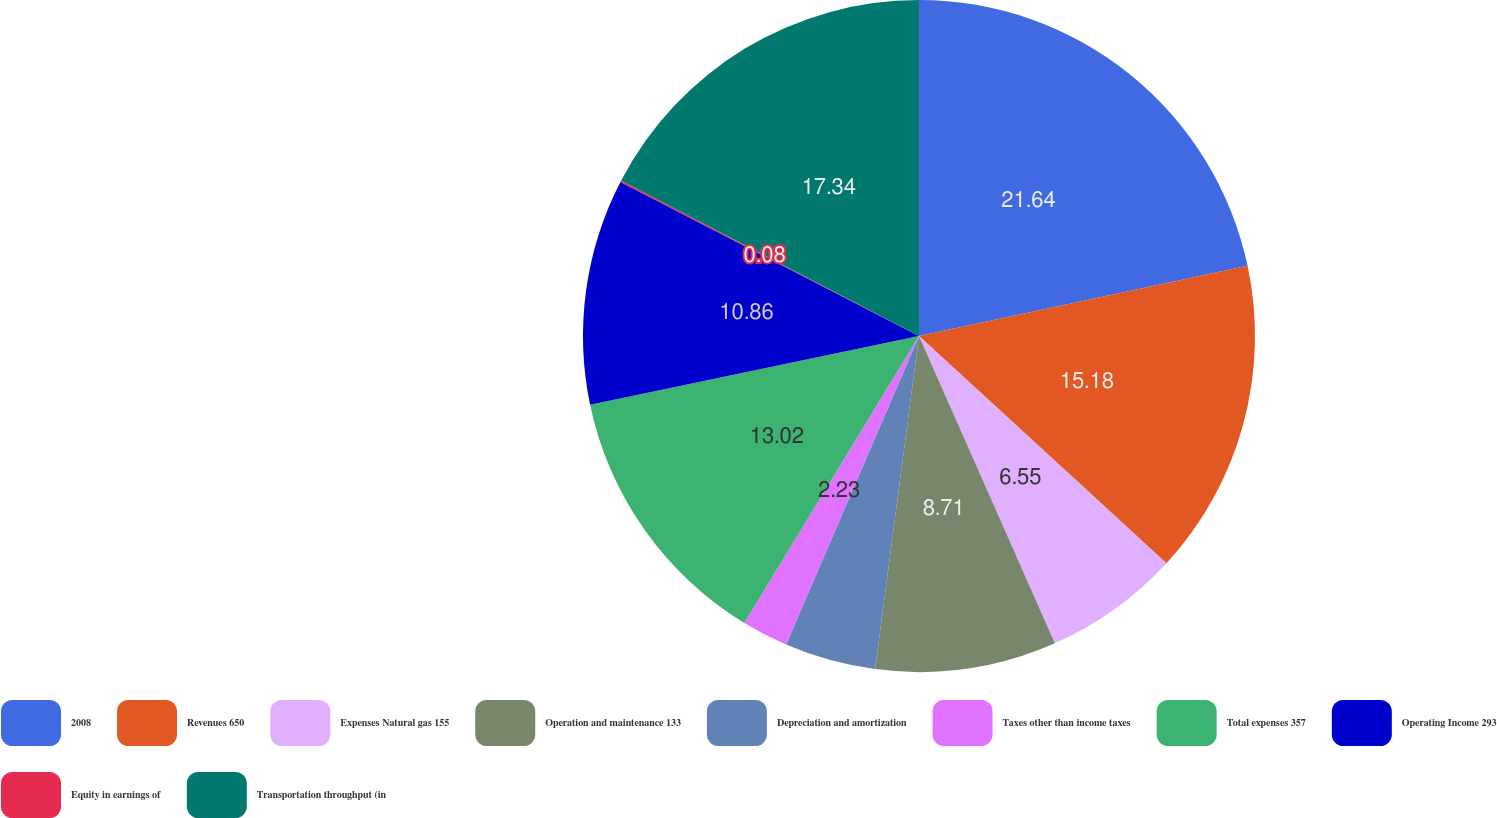Convert chart to OTSL. <chart><loc_0><loc_0><loc_500><loc_500><pie_chart><fcel>2008<fcel>Revenues 650<fcel>Expenses Natural gas 155<fcel>Operation and maintenance 133<fcel>Depreciation and amortization<fcel>Taxes other than income taxes<fcel>Total expenses 357<fcel>Operating Income 293<fcel>Equity in earnings of<fcel>Transportation throughput (in<nl><fcel>21.65%<fcel>15.18%<fcel>6.55%<fcel>8.71%<fcel>4.39%<fcel>2.23%<fcel>13.02%<fcel>10.86%<fcel>0.08%<fcel>17.34%<nl></chart> 